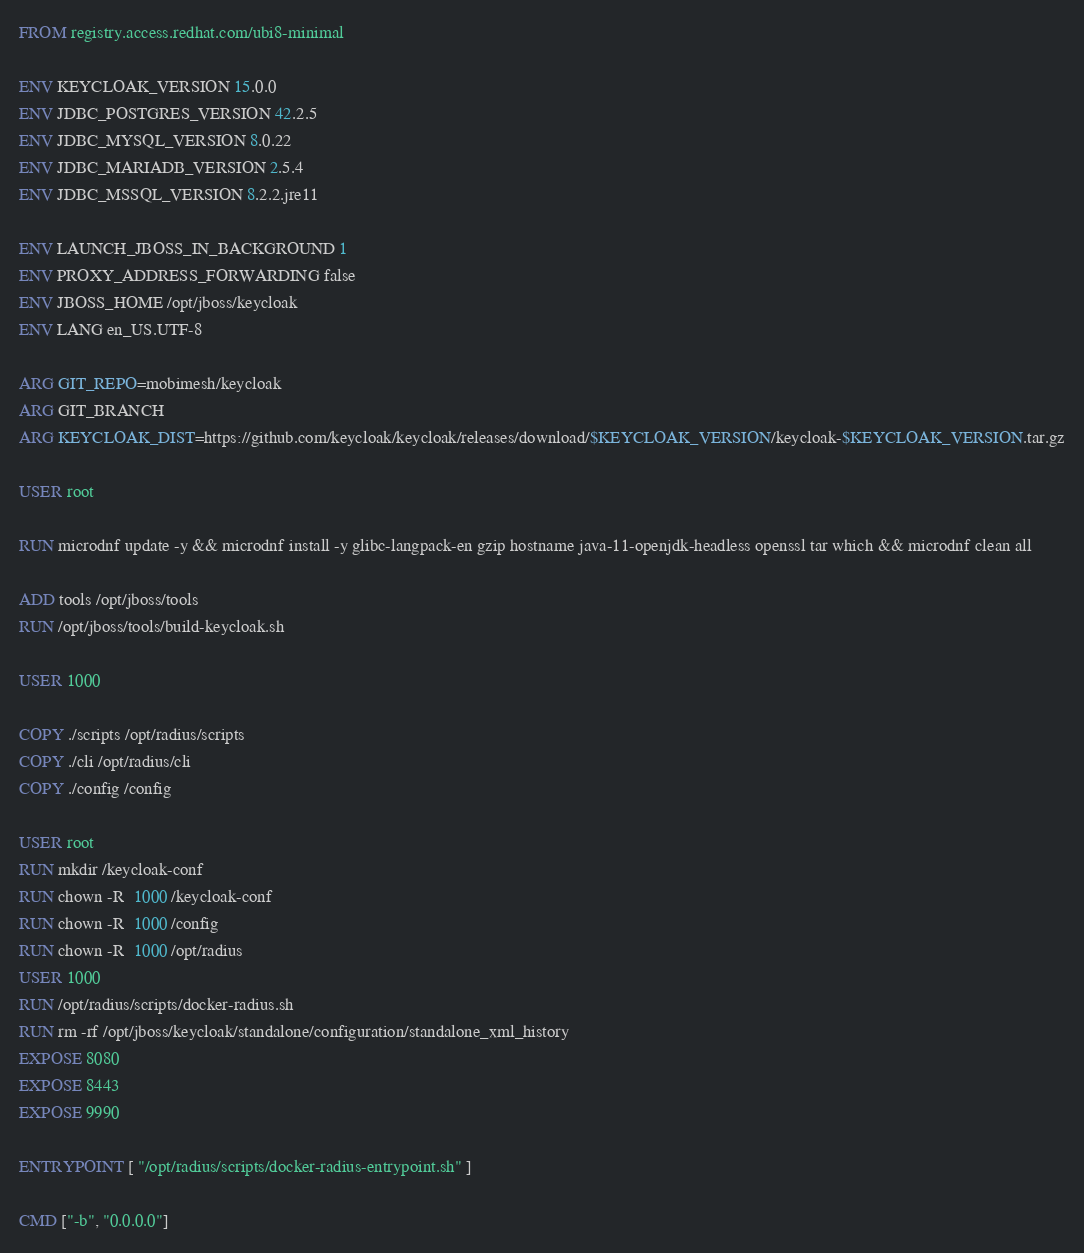<code> <loc_0><loc_0><loc_500><loc_500><_Dockerfile_>FROM registry.access.redhat.com/ubi8-minimal

ENV KEYCLOAK_VERSION 15.0.0
ENV JDBC_POSTGRES_VERSION 42.2.5
ENV JDBC_MYSQL_VERSION 8.0.22
ENV JDBC_MARIADB_VERSION 2.5.4
ENV JDBC_MSSQL_VERSION 8.2.2.jre11

ENV LAUNCH_JBOSS_IN_BACKGROUND 1
ENV PROXY_ADDRESS_FORWARDING false
ENV JBOSS_HOME /opt/jboss/keycloak
ENV LANG en_US.UTF-8

ARG GIT_REPO=mobimesh/keycloak
ARG GIT_BRANCH
ARG KEYCLOAK_DIST=https://github.com/keycloak/keycloak/releases/download/$KEYCLOAK_VERSION/keycloak-$KEYCLOAK_VERSION.tar.gz

USER root

RUN microdnf update -y && microdnf install -y glibc-langpack-en gzip hostname java-11-openjdk-headless openssl tar which && microdnf clean all

ADD tools /opt/jboss/tools
RUN /opt/jboss/tools/build-keycloak.sh

USER 1000

COPY ./scripts /opt/radius/scripts
COPY ./cli /opt/radius/cli
COPY ./config /config

USER root
RUN mkdir /keycloak-conf
RUN chown -R  1000 /keycloak-conf
RUN chown -R  1000 /config
RUN chown -R  1000 /opt/radius
USER 1000
RUN /opt/radius/scripts/docker-radius.sh
RUN rm -rf /opt/jboss/keycloak/standalone/configuration/standalone_xml_history
EXPOSE 8080
EXPOSE 8443
EXPOSE 9990

ENTRYPOINT [ "/opt/radius/scripts/docker-radius-entrypoint.sh" ]

CMD ["-b", "0.0.0.0"]
</code> 